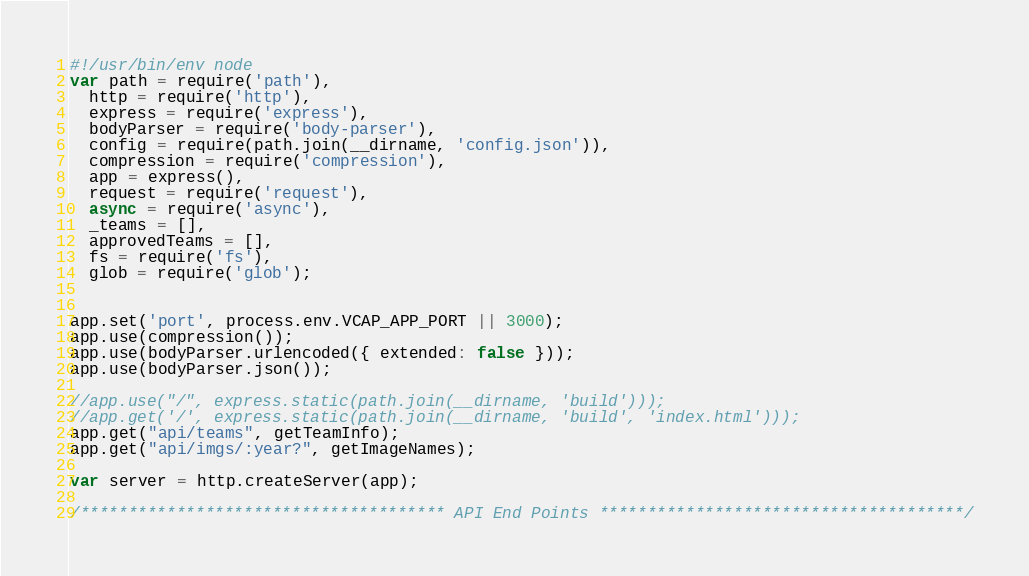<code> <loc_0><loc_0><loc_500><loc_500><_JavaScript_>#!/usr/bin/env node
var path = require('path'),
  http = require('http'),
  express = require('express'),
  bodyParser = require('body-parser'),
  config = require(path.join(__dirname, 'config.json')),
  compression = require('compression'),
  app = express(),
  request = require('request'),
  async = require('async'),
  _teams = [],
  approvedTeams = [],
  fs = require('fs'),
  glob = require('glob');


app.set('port', process.env.VCAP_APP_PORT || 3000);
app.use(compression());
app.use(bodyParser.urlencoded({ extended: false }));
app.use(bodyParser.json());

//app.use("/", express.static(path.join(__dirname, 'build')));
//app.get('/', express.static(path.join(__dirname, 'build', 'index.html')));
app.get("api/teams", getTeamInfo);
app.get("api/imgs/:year?", getImageNames);

var server = http.createServer(app);

/************************************** API End Points **************************************/
</code> 